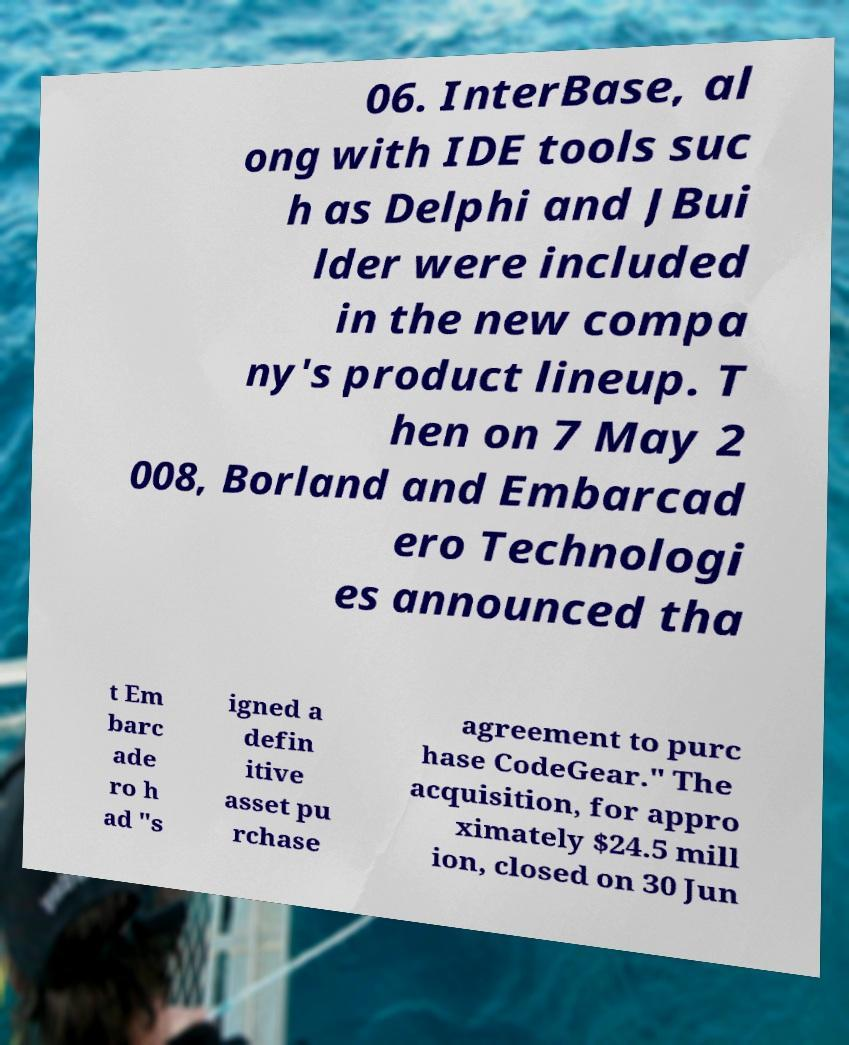I need the written content from this picture converted into text. Can you do that? 06. InterBase, al ong with IDE tools suc h as Delphi and JBui lder were included in the new compa ny's product lineup. T hen on 7 May 2 008, Borland and Embarcad ero Technologi es announced tha t Em barc ade ro h ad "s igned a defin itive asset pu rchase agreement to purc hase CodeGear." The acquisition, for appro ximately $24.5 mill ion, closed on 30 Jun 